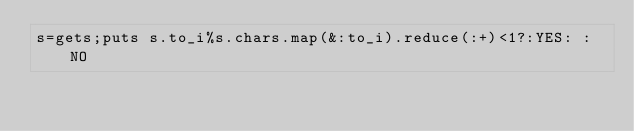<code> <loc_0><loc_0><loc_500><loc_500><_Ruby_>s=gets;puts s.to_i%s.chars.map(&:to_i).reduce(:+)<1?:YES: :NO</code> 